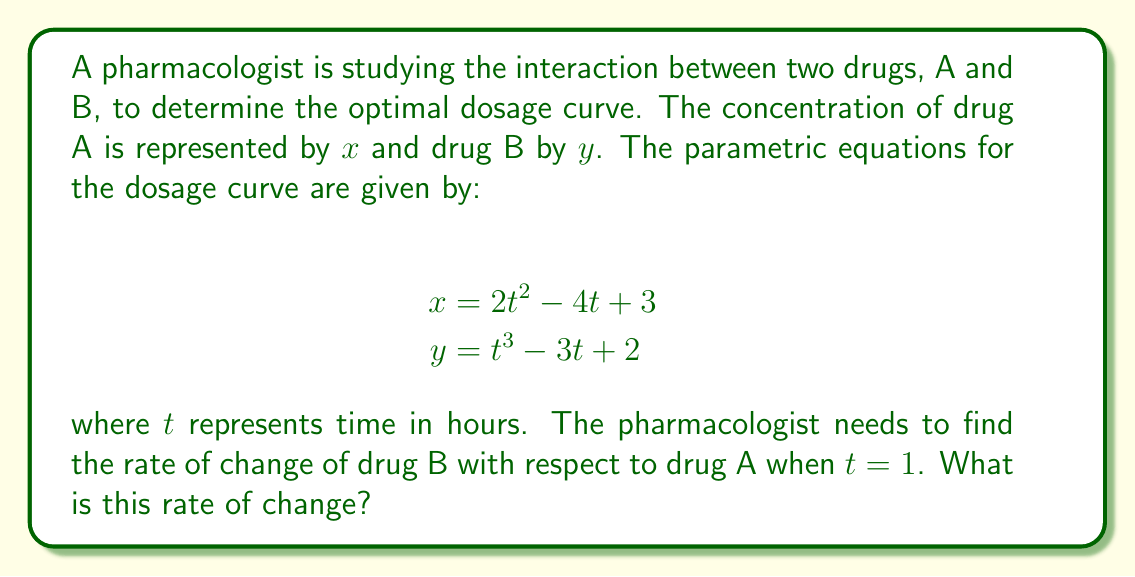Give your solution to this math problem. To find the rate of change of drug B with respect to drug A, we need to calculate $\frac{dy}{dx}$ using the chain rule:

1) First, we calculate $\frac{dx}{dt}$ and $\frac{dy}{dt}$:

   $\frac{dx}{dt} = 4t - 4$
   $\frac{dy}{dt} = 3t^2 - 3$

2) Then, we use the chain rule: $\frac{dy}{dx} = \frac{dy/dt}{dx/dt}$

3) Substituting the expressions:

   $$\frac{dy}{dx} = \frac{3t^2 - 3}{4t - 4}$$

4) Now, we need to evaluate this at $t = 1$:

   $$\frac{dy}{dx}\bigg|_{t=1} = \frac{3(1)^2 - 3}{4(1) - 4} = \frac{3 - 3}{4 - 4} = \frac{0}{0}$$

5) This results in an indeterminate form. We need to use L'Hôpital's rule:

   $$\lim_{t \to 1} \frac{dy}{dx} = \lim_{t \to 1} \frac{3t^2 - 3}{4t - 4} = \lim_{t \to 1} \frac{6t}{4} = \frac{6(1)}{4} = \frac{3}{2}$$

Therefore, the rate of change of drug B with respect to drug A when $t = 1$ is $\frac{3}{2}$ or 1.5.
Answer: $\frac{3}{2}$ 